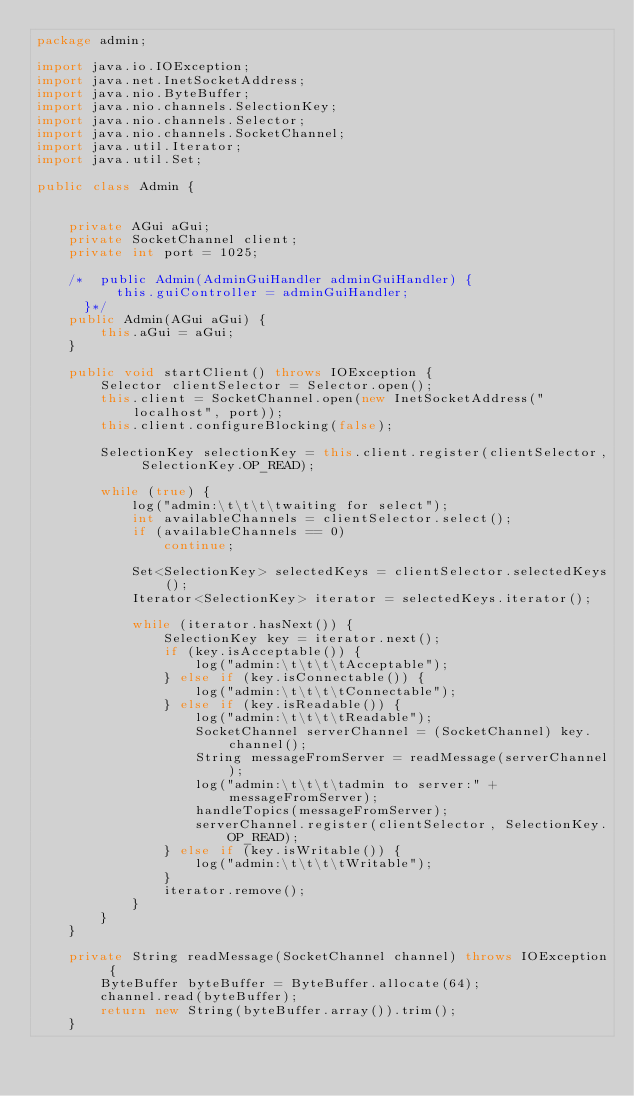<code> <loc_0><loc_0><loc_500><loc_500><_Java_>package admin;

import java.io.IOException;
import java.net.InetSocketAddress;
import java.nio.ByteBuffer;
import java.nio.channels.SelectionKey;
import java.nio.channels.Selector;
import java.nio.channels.SocketChannel;
import java.util.Iterator;
import java.util.Set;

public class Admin {


    private AGui aGui;
    private SocketChannel client;
    private int port = 1025;

    /*  public Admin(AdminGuiHandler adminGuiHandler) {
          this.guiController = adminGuiHandler;
      }*/
    public Admin(AGui aGui) {
        this.aGui = aGui;
    }

    public void startClient() throws IOException {
        Selector clientSelector = Selector.open();
        this.client = SocketChannel.open(new InetSocketAddress("localhost", port));
        this.client.configureBlocking(false);

        SelectionKey selectionKey = this.client.register(clientSelector, SelectionKey.OP_READ);

        while (true) {
            log("admin:\t\t\t\twaiting for select");
            int availableChannels = clientSelector.select();
            if (availableChannels == 0)
                continue;

            Set<SelectionKey> selectedKeys = clientSelector.selectedKeys();
            Iterator<SelectionKey> iterator = selectedKeys.iterator();

            while (iterator.hasNext()) {
                SelectionKey key = iterator.next();
                if (key.isAcceptable()) {
                    log("admin:\t\t\t\tAcceptable");
                } else if (key.isConnectable()) {
                    log("admin:\t\t\t\tConnectable");
                } else if (key.isReadable()) {
                    log("admin:\t\t\t\tReadable");
                    SocketChannel serverChannel = (SocketChannel) key.channel();
                    String messageFromServer = readMessage(serverChannel);
                    log("admin:\t\t\t\tadmin to server:" + messageFromServer);
                    handleTopics(messageFromServer);
                    serverChannel.register(clientSelector, SelectionKey.OP_READ);
                } else if (key.isWritable()) {
                    log("admin:\t\t\t\tWritable");
                }
                iterator.remove();
            }
        }
    }

    private String readMessage(SocketChannel channel) throws IOException {
        ByteBuffer byteBuffer = ByteBuffer.allocate(64);
        channel.read(byteBuffer);
        return new String(byteBuffer.array()).trim();
    }
</code> 